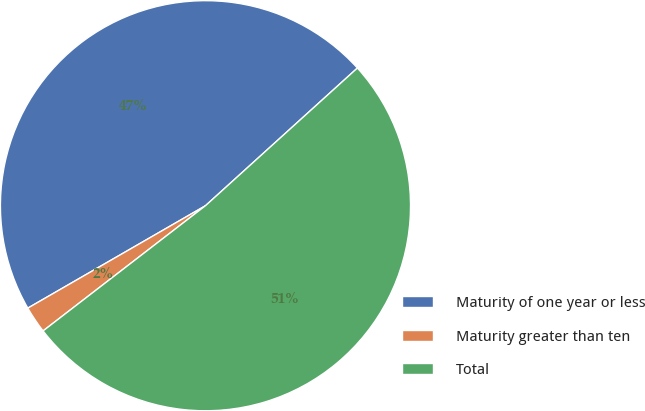Convert chart to OTSL. <chart><loc_0><loc_0><loc_500><loc_500><pie_chart><fcel>Maturity of one year or less<fcel>Maturity greater than ten<fcel>Total<nl><fcel>46.6%<fcel>2.13%<fcel>51.26%<nl></chart> 